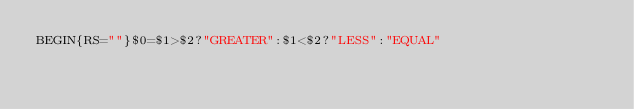Convert code to text. <code><loc_0><loc_0><loc_500><loc_500><_Awk_>BEGIN{RS=""}$0=$1>$2?"GREATER":$1<$2?"LESS":"EQUAL"</code> 